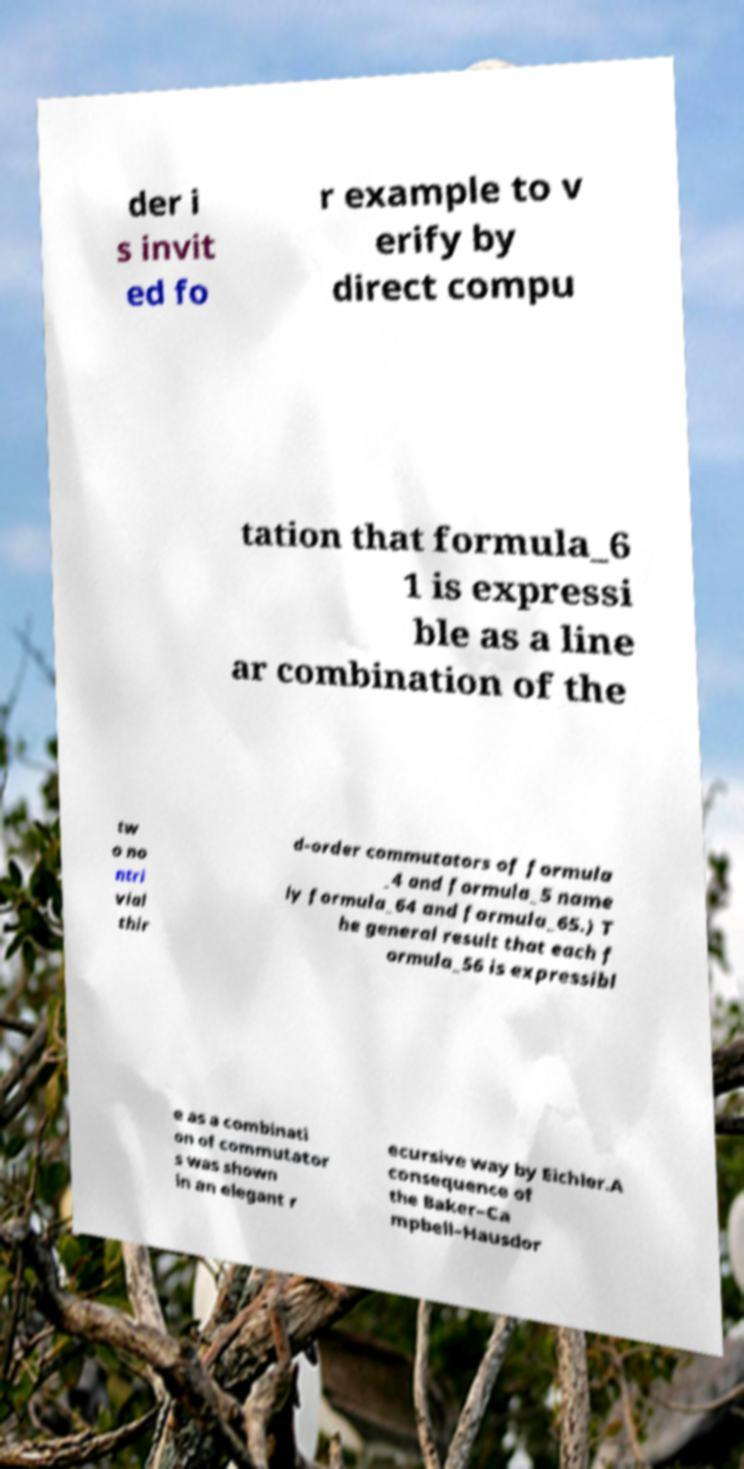Please identify and transcribe the text found in this image. der i s invit ed fo r example to v erify by direct compu tation that formula_6 1 is expressi ble as a line ar combination of the tw o no ntri vial thir d-order commutators of formula _4 and formula_5 name ly formula_64 and formula_65.) T he general result that each f ormula_56 is expressibl e as a combinati on of commutator s was shown in an elegant r ecursive way by Eichler.A consequence of the Baker–Ca mpbell–Hausdor 